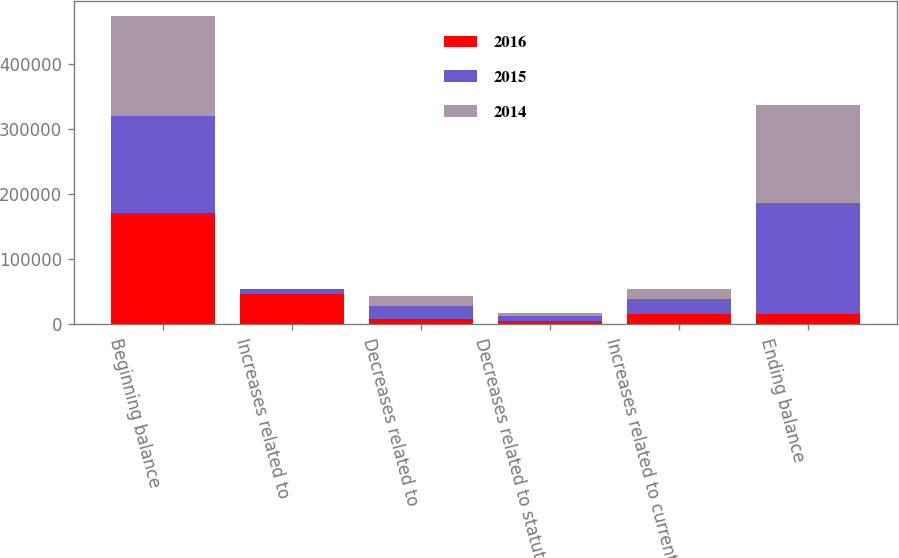<chart> <loc_0><loc_0><loc_500><loc_500><stacked_bar_chart><ecel><fcel>Beginning balance<fcel>Increases related to<fcel>Decreases related to<fcel>Decreases related to statute<fcel>Increases related to current<fcel>Ending balance<nl><fcel>2016<fcel>170654<fcel>46245<fcel>7954<fcel>4591<fcel>16315<fcel>16315<nl><fcel>2015<fcel>149878<fcel>8381<fcel>20197<fcel>9031<fcel>23179<fcel>170654<nl><fcel>2014<fcel>152845<fcel>341<fcel>15016<fcel>4069<fcel>14669<fcel>149878<nl></chart> 